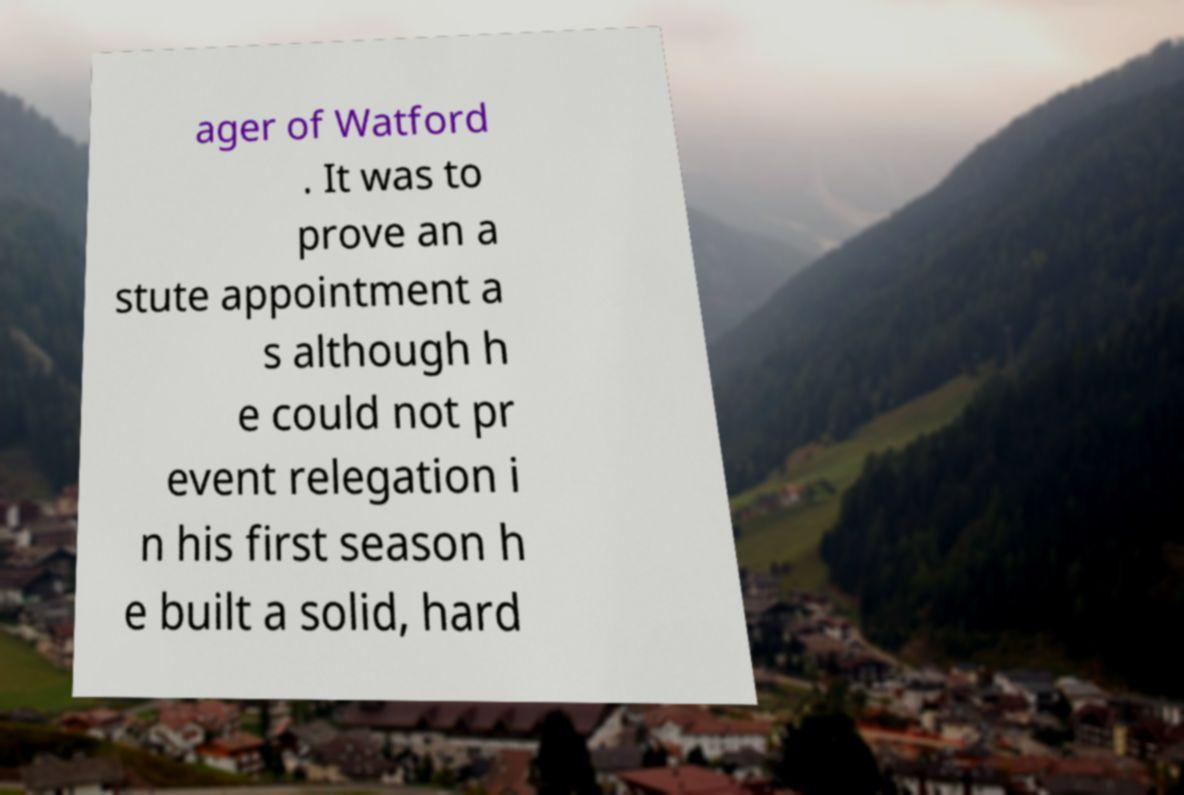I need the written content from this picture converted into text. Can you do that? ager of Watford . It was to prove an a stute appointment a s although h e could not pr event relegation i n his first season h e built a solid, hard 